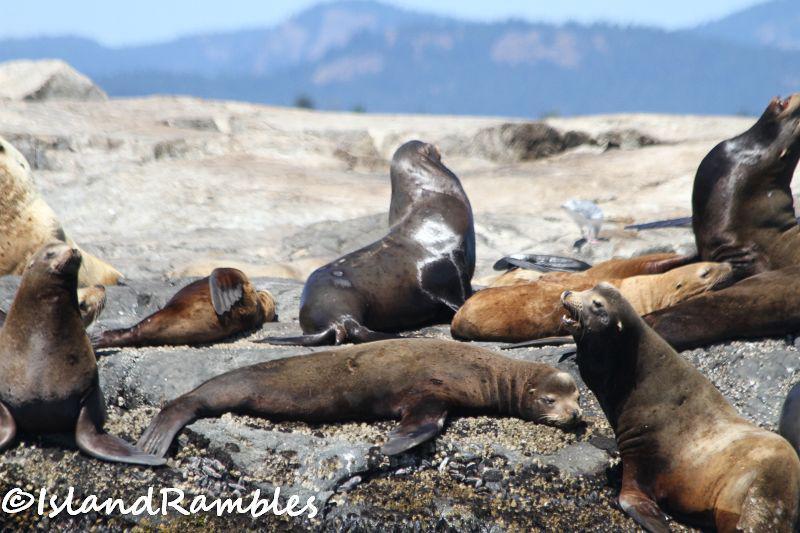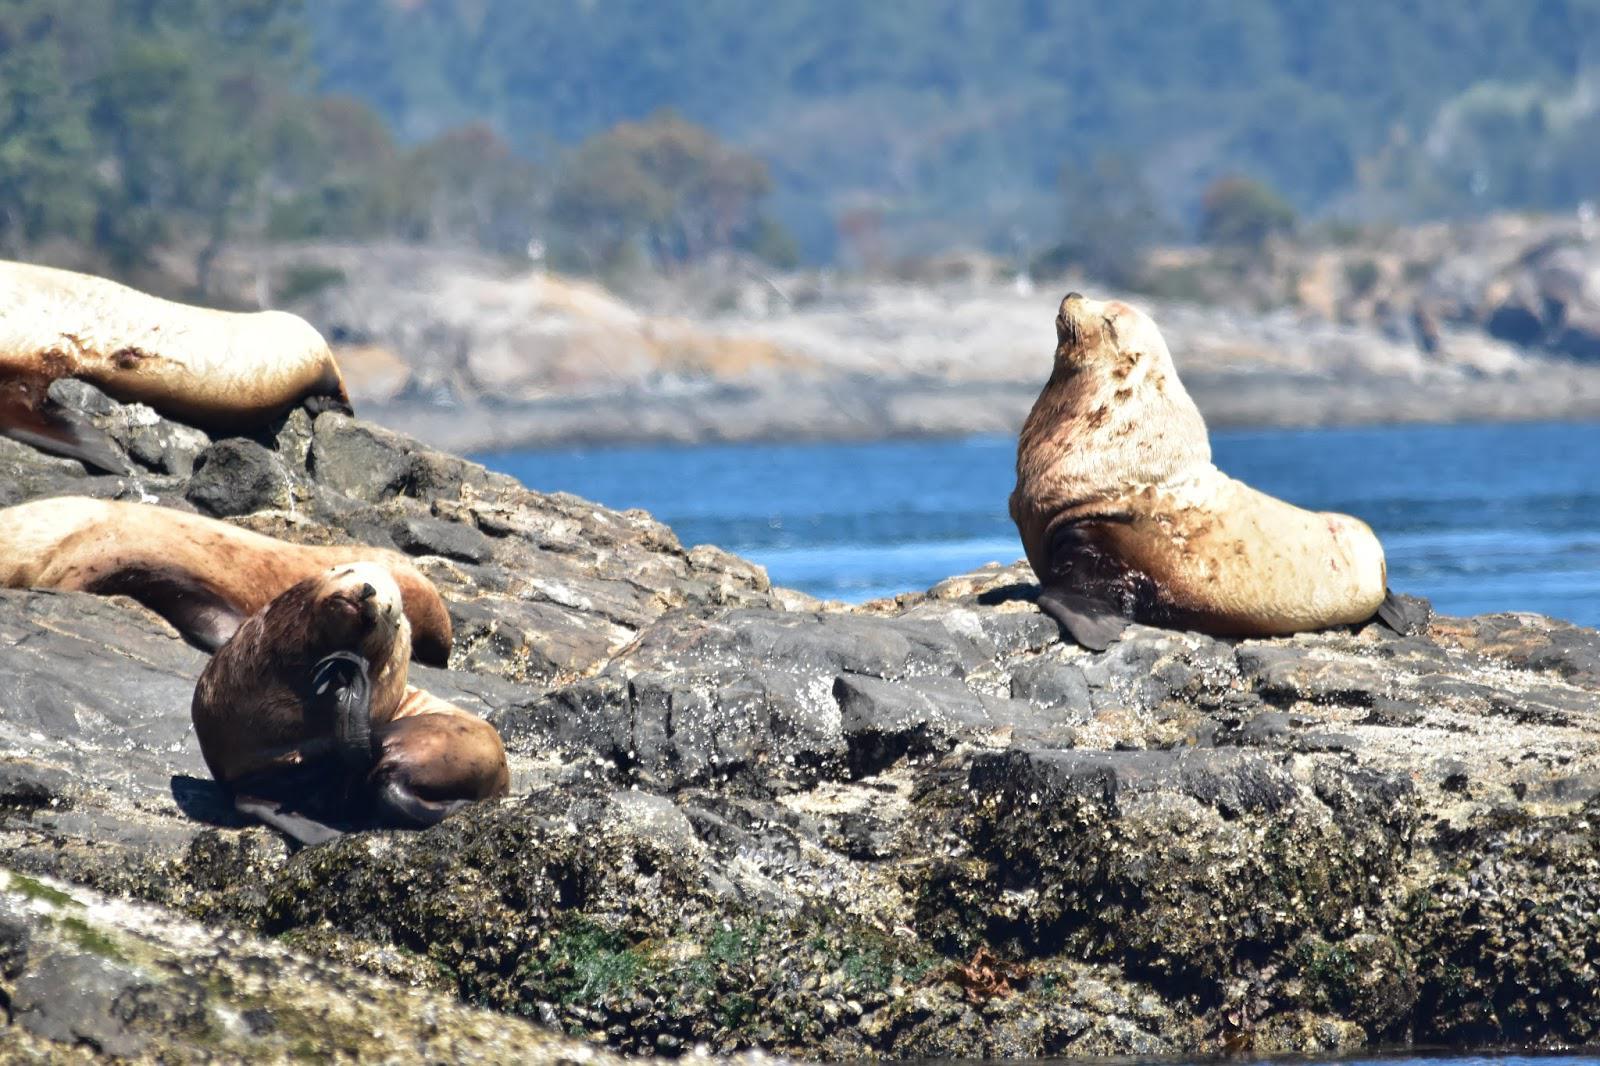The first image is the image on the left, the second image is the image on the right. Considering the images on both sides, is "There is no land on the horizon of the image on the left." valid? Answer yes or no. No. 